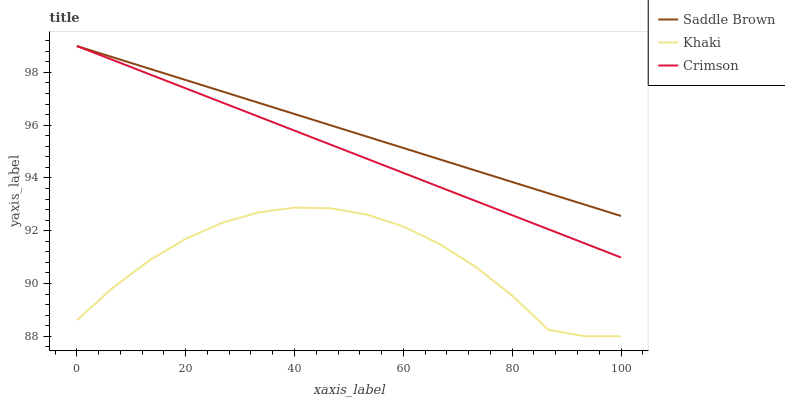Does Khaki have the minimum area under the curve?
Answer yes or no. Yes. Does Saddle Brown have the maximum area under the curve?
Answer yes or no. Yes. Does Saddle Brown have the minimum area under the curve?
Answer yes or no. No. Does Khaki have the maximum area under the curve?
Answer yes or no. No. Is Crimson the smoothest?
Answer yes or no. Yes. Is Khaki the roughest?
Answer yes or no. Yes. Is Saddle Brown the smoothest?
Answer yes or no. No. Is Saddle Brown the roughest?
Answer yes or no. No. Does Khaki have the lowest value?
Answer yes or no. Yes. Does Saddle Brown have the lowest value?
Answer yes or no. No. Does Saddle Brown have the highest value?
Answer yes or no. Yes. Does Khaki have the highest value?
Answer yes or no. No. Is Khaki less than Saddle Brown?
Answer yes or no. Yes. Is Saddle Brown greater than Khaki?
Answer yes or no. Yes. Does Saddle Brown intersect Crimson?
Answer yes or no. Yes. Is Saddle Brown less than Crimson?
Answer yes or no. No. Is Saddle Brown greater than Crimson?
Answer yes or no. No. Does Khaki intersect Saddle Brown?
Answer yes or no. No. 